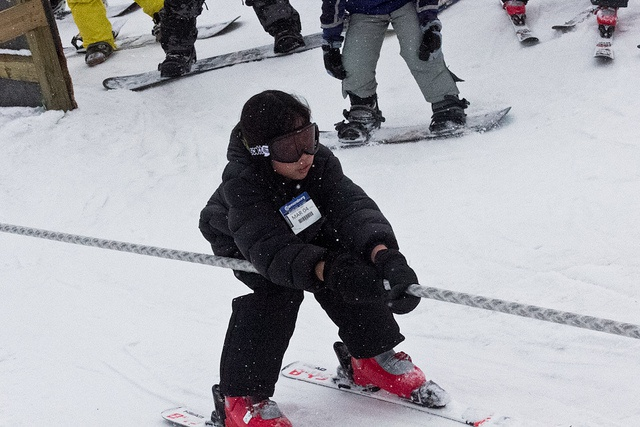Describe the objects in this image and their specific colors. I can see people in black, gray, lightgray, and maroon tones, people in black, gray, and lightgray tones, people in black, gray, and lightgray tones, snowboard in black, darkgray, gray, and lightgray tones, and skis in black, lightgray, darkgray, and gray tones in this image. 